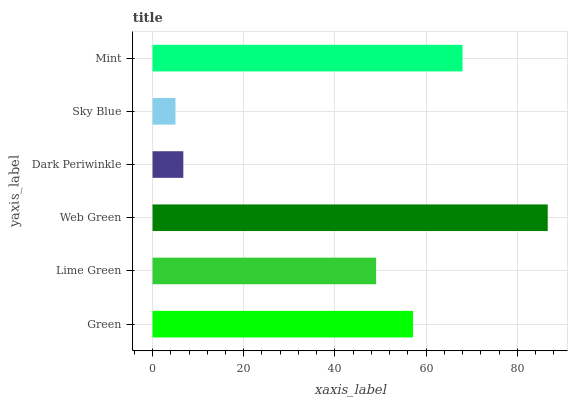Is Sky Blue the minimum?
Answer yes or no. Yes. Is Web Green the maximum?
Answer yes or no. Yes. Is Lime Green the minimum?
Answer yes or no. No. Is Lime Green the maximum?
Answer yes or no. No. Is Green greater than Lime Green?
Answer yes or no. Yes. Is Lime Green less than Green?
Answer yes or no. Yes. Is Lime Green greater than Green?
Answer yes or no. No. Is Green less than Lime Green?
Answer yes or no. No. Is Green the high median?
Answer yes or no. Yes. Is Lime Green the low median?
Answer yes or no. Yes. Is Sky Blue the high median?
Answer yes or no. No. Is Dark Periwinkle the low median?
Answer yes or no. No. 